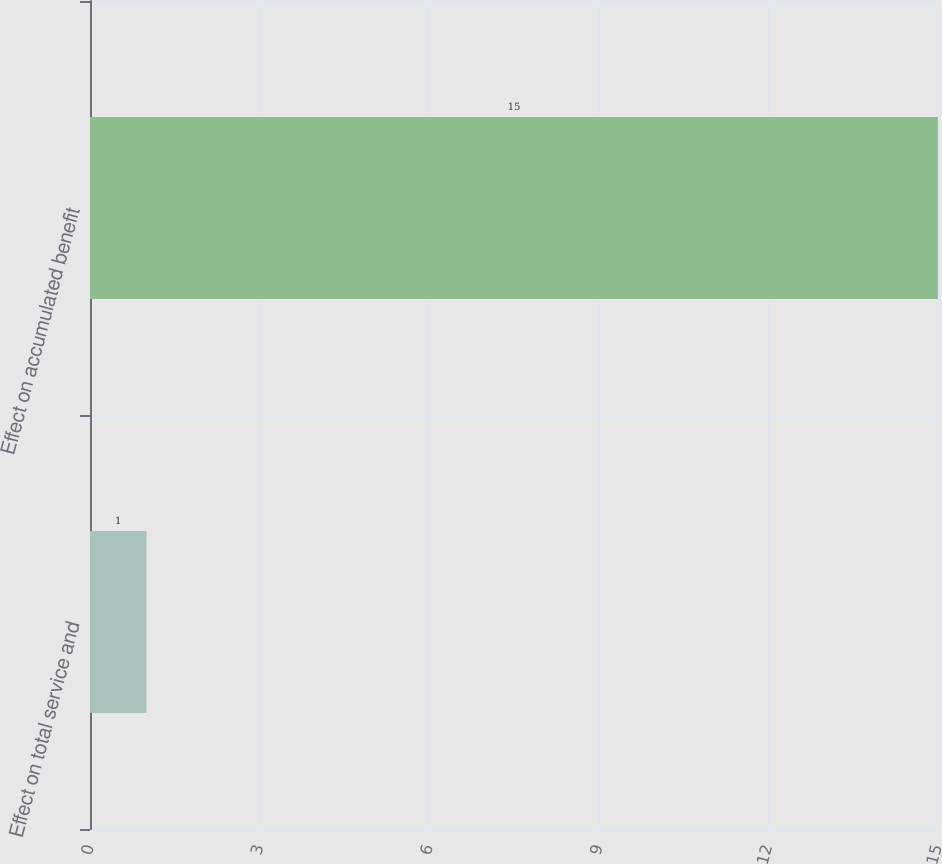Convert chart. <chart><loc_0><loc_0><loc_500><loc_500><bar_chart><fcel>Effect on total service and<fcel>Effect on accumulated benefit<nl><fcel>1<fcel>15<nl></chart> 